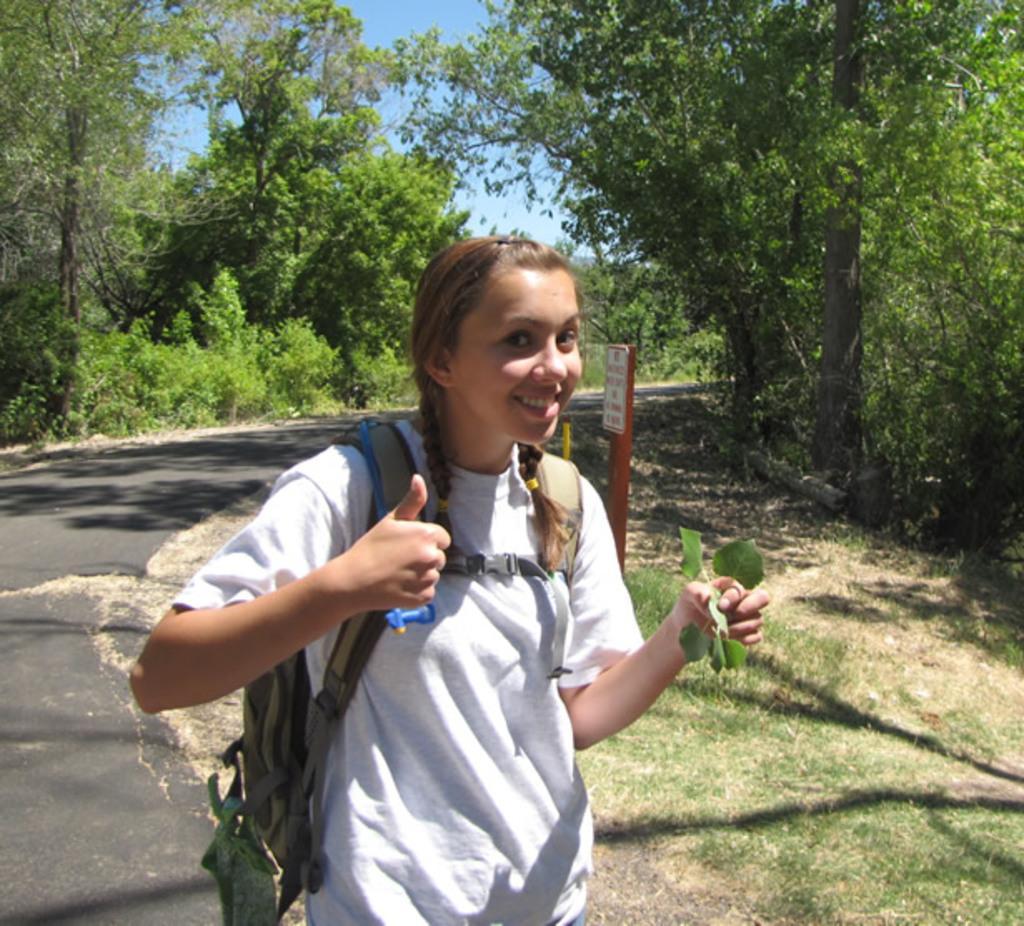How would you summarize this image in a sentence or two? In this image I can see the person wearing the white color dress and the bag. The person is on the road. To the side of the person I can see the board, many trees and the sky. 